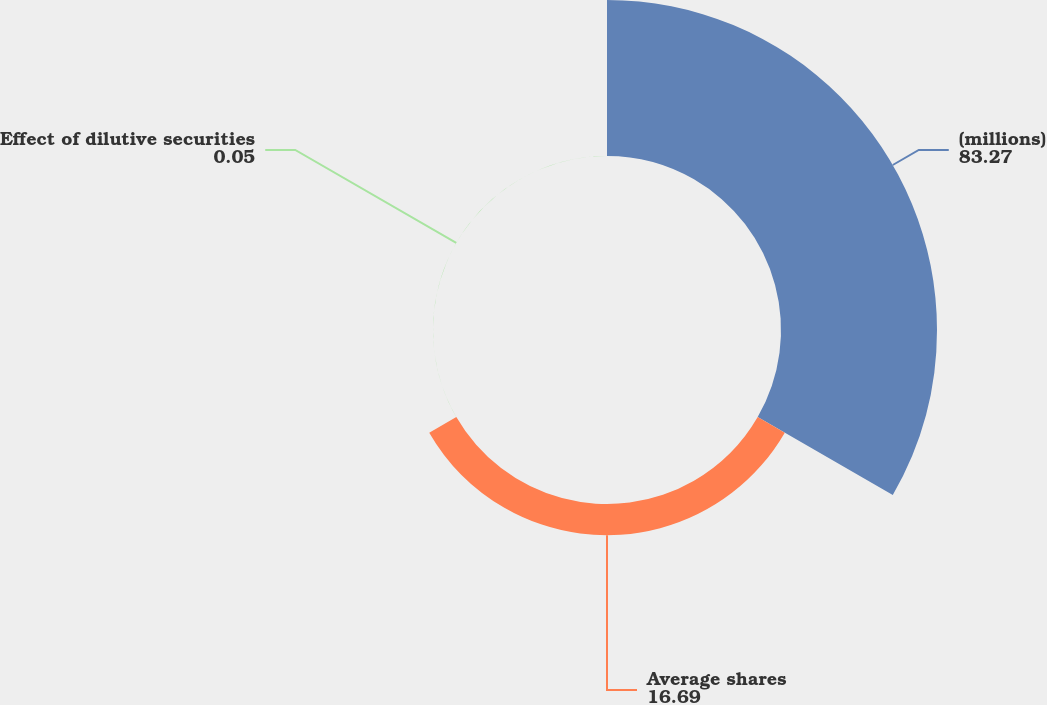Convert chart. <chart><loc_0><loc_0><loc_500><loc_500><pie_chart><fcel>(millions)<fcel>Average shares<fcel>Effect of dilutive securities<nl><fcel>83.27%<fcel>16.69%<fcel>0.05%<nl></chart> 